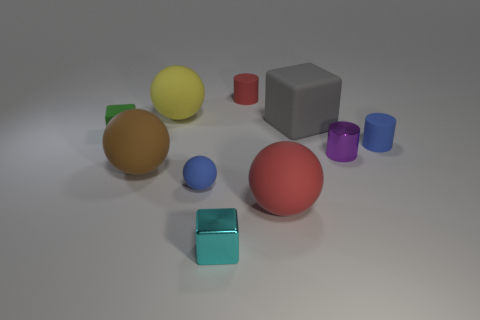Subtract all small blocks. How many blocks are left? 1 Subtract all yellow spheres. How many spheres are left? 3 Subtract all balls. How many objects are left? 6 Subtract 2 cylinders. How many cylinders are left? 1 Subtract 0 gray balls. How many objects are left? 10 Subtract all brown cylinders. Subtract all yellow blocks. How many cylinders are left? 3 Subtract all red balls. How many yellow cylinders are left? 0 Subtract all blue cylinders. Subtract all big brown things. How many objects are left? 8 Add 1 big brown rubber balls. How many big brown rubber balls are left? 2 Add 9 small metal blocks. How many small metal blocks exist? 10 